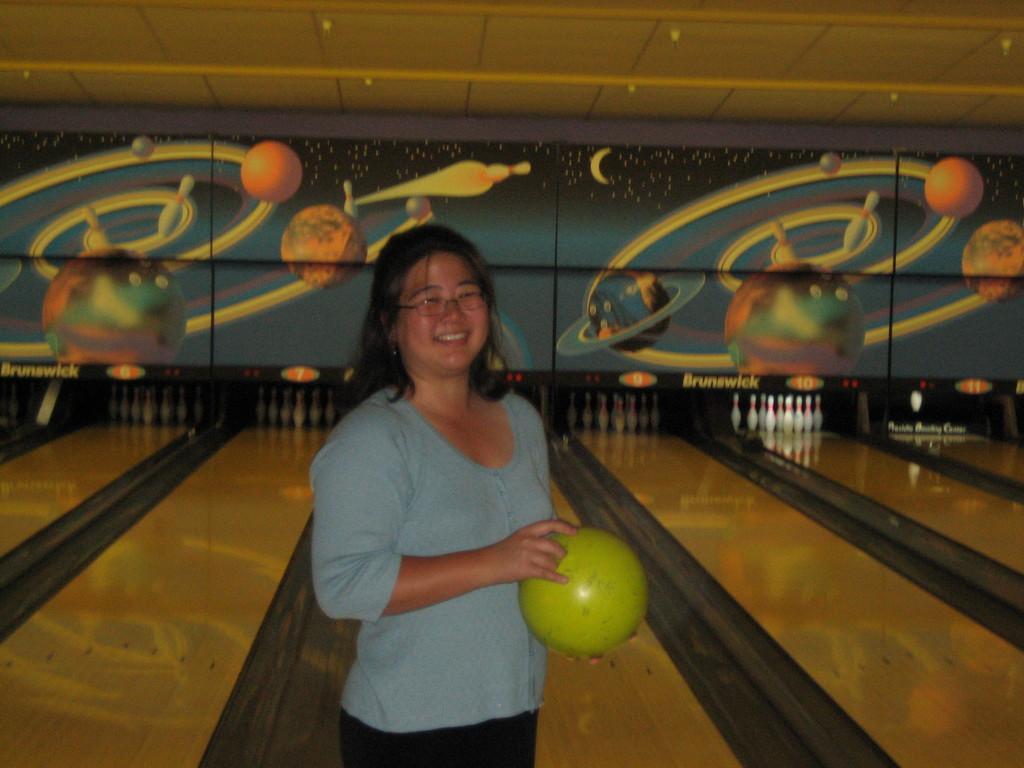Please provide a concise description of this image. In this image I can see a person standing holding a ball. The person is wearing blue shirt, black pant and the ball is in green color. Background the wall is in multicolor. 